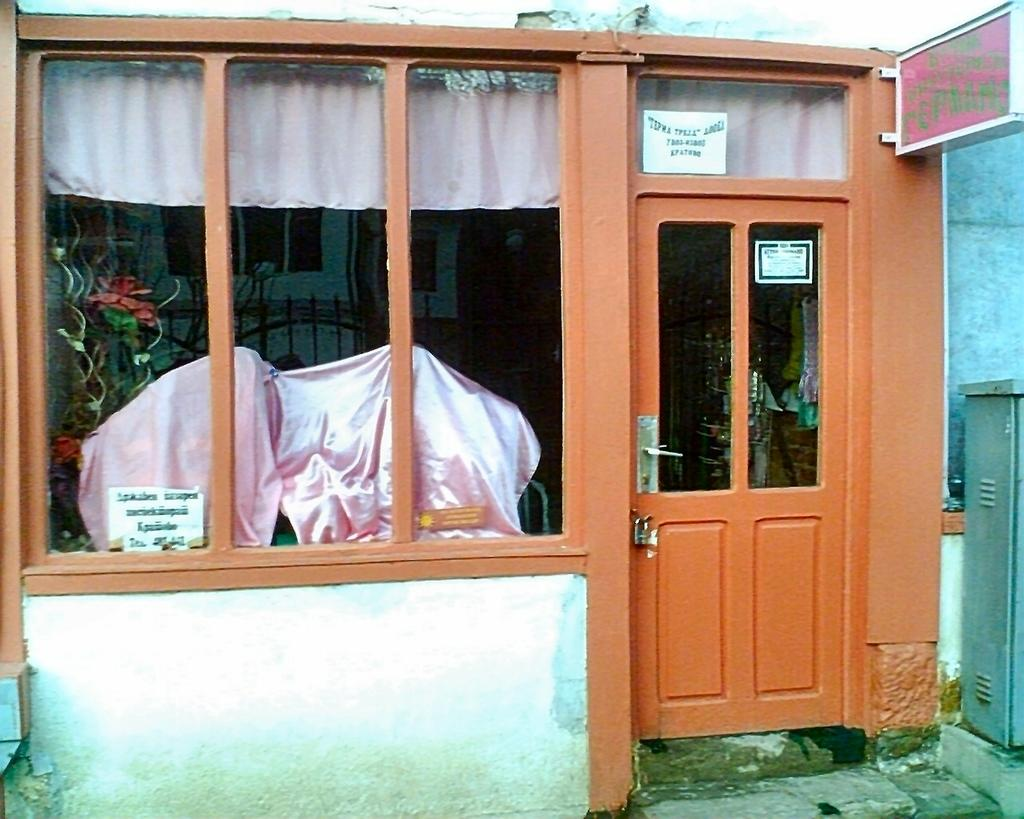What is the main subject of the image? The main subject of the image is a house. Can you describe the house in the image? The house is in the center of the image and has a door and windows. How many cows are present in the image? There are no cows present in the image; it features a house with a door and windows. What type of feast is being prepared in the image? There is no indication of a feast or any food preparation in the image. 